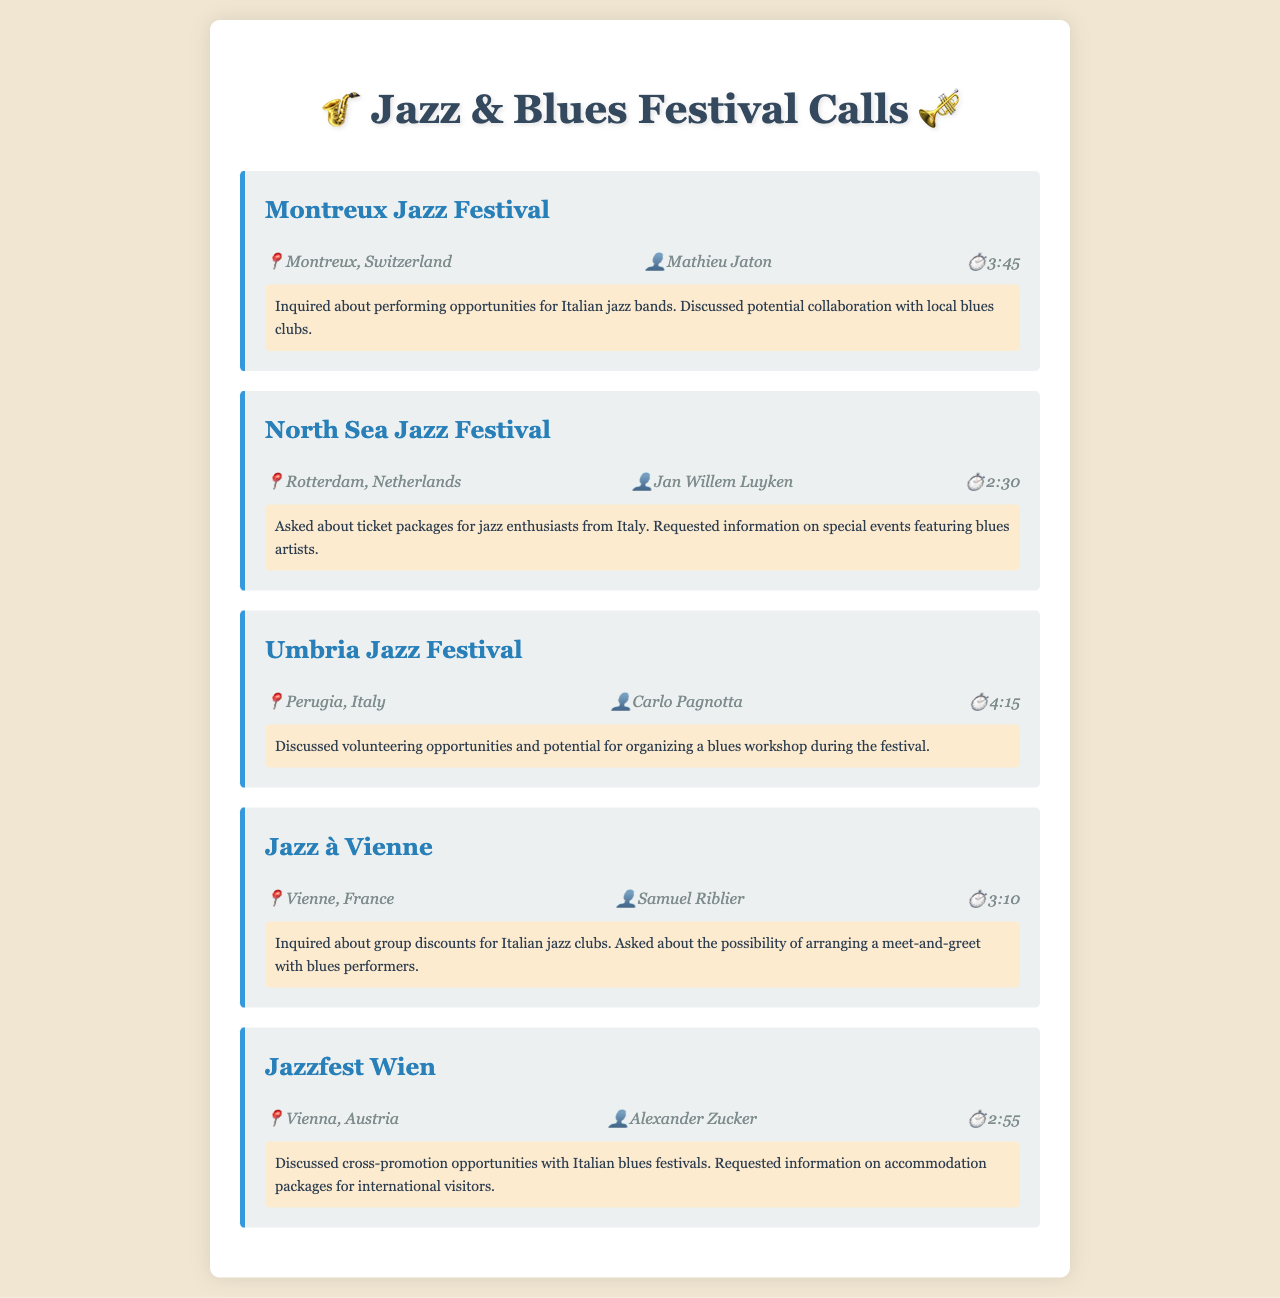what is the location of the Montreux Jazz Festival? The document states that the Montreux Jazz Festival is located in Montreux, Switzerland.
Answer: Montreux, Switzerland who did you speak with at the North Sea Jazz Festival? The document lists Jan Willem Luyken as the contact person for the North Sea Jazz Festival.
Answer: Jan Willem Luyken how long was the call with Umbria Jazz Festival? According to the document, the call duration with Umbria Jazz Festival was 4:15 minutes.
Answer: 4:15 which festival is located in Vienne, France? The call record specifies that the Jazz à Vienne festival is located in Vienne, France.
Answer: Jazz à Vienne what opportunity was discussed with the Montreux Jazz Festival? The document mentions inquiring about performing opportunities for Italian jazz bands as the discussion point.
Answer: Performing opportunities for Italian jazz bands how did you intend to promote collaboration with Italian blues festivals? The document indicates that you discussed cross-promotion opportunities with Italian blues festivals during the call with Jazzfest Wien.
Answer: Cross-promotion opportunities what type of event did you ask about at Jazz à Vienne? The document notes that you asked about arranging a meet-and-greet with blues performers during the call with Jazz à Vienne.
Answer: Meet-and-greet with blues performers what was requested regarding ticket packages at the North Sea Jazz Festival? The document states that information was requested on ticket packages for jazz enthusiasts from Italy.
Answer: Ticket packages for jazz enthusiasts from Italy who was your contact person at Jazzfest Wien? According to the call record, the contact person at Jazzfest Wien is Alexander Zucker.
Answer: Alexander Zucker 